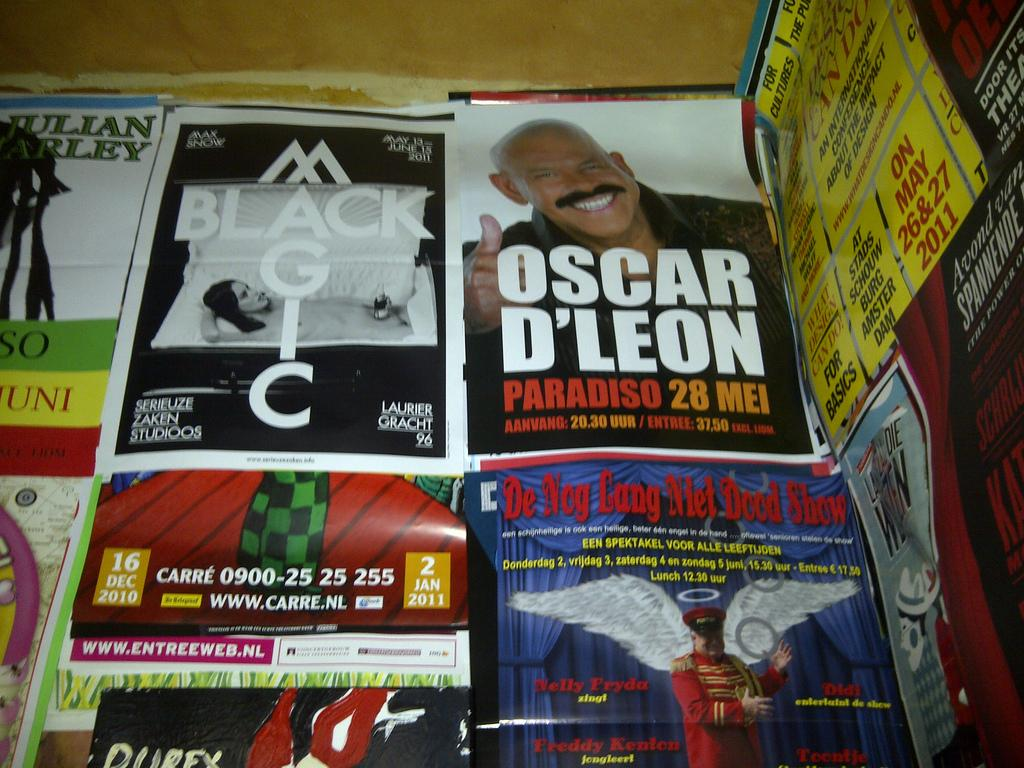<image>
Relay a brief, clear account of the picture shown. A magazine features Oscar D'Leon on the cover sits next to a magazine called Black Magic 